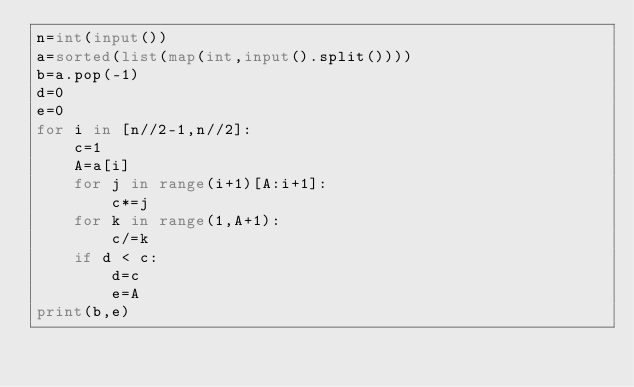Convert code to text. <code><loc_0><loc_0><loc_500><loc_500><_Python_>n=int(input())
a=sorted(list(map(int,input().split())))
b=a.pop(-1)
d=0
e=0
for i in [n//2-1,n//2]:
    c=1
    A=a[i]
    for j in range(i+1)[A:i+1]:
        c*=j
    for k in range(1,A+1):
        c/=k
    if d < c:
        d=c
        e=A
print(b,e)
</code> 